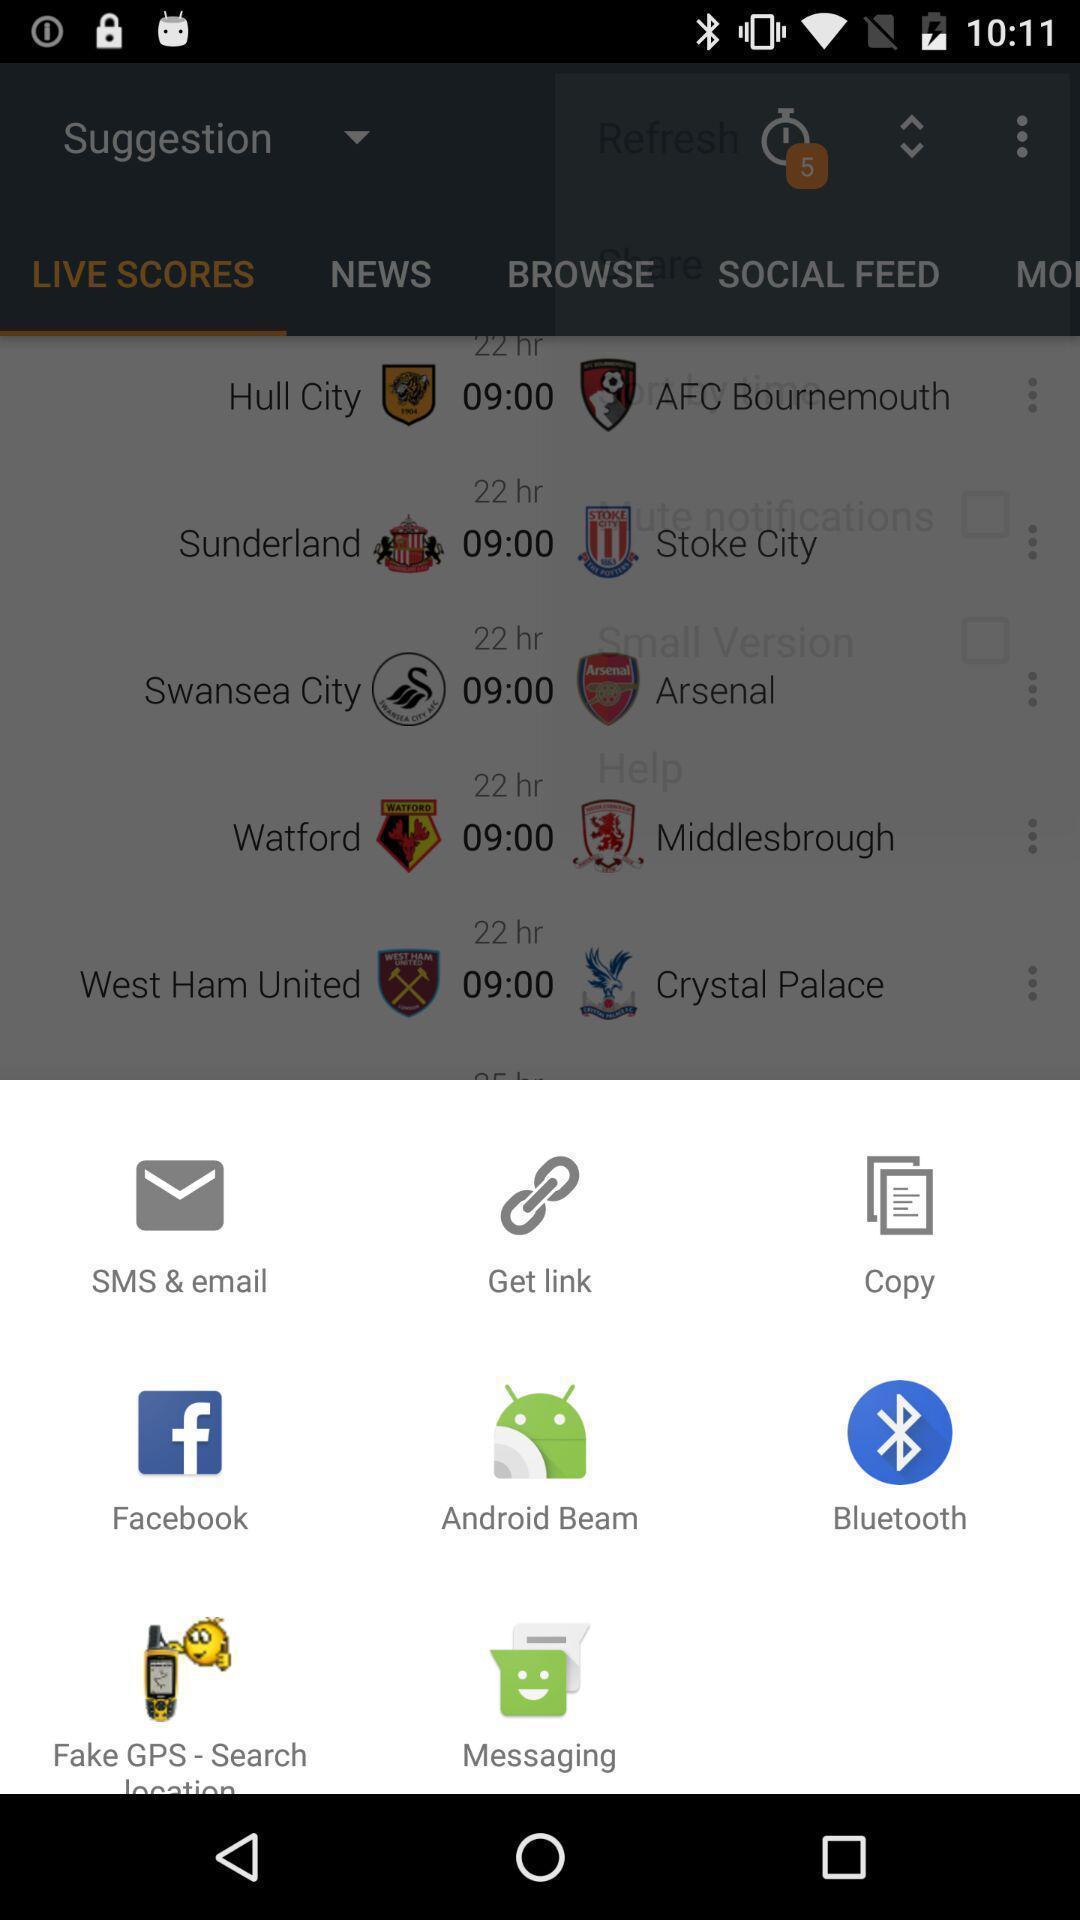Describe the visual elements of this screenshot. Pop-up displaying different applications to open. 